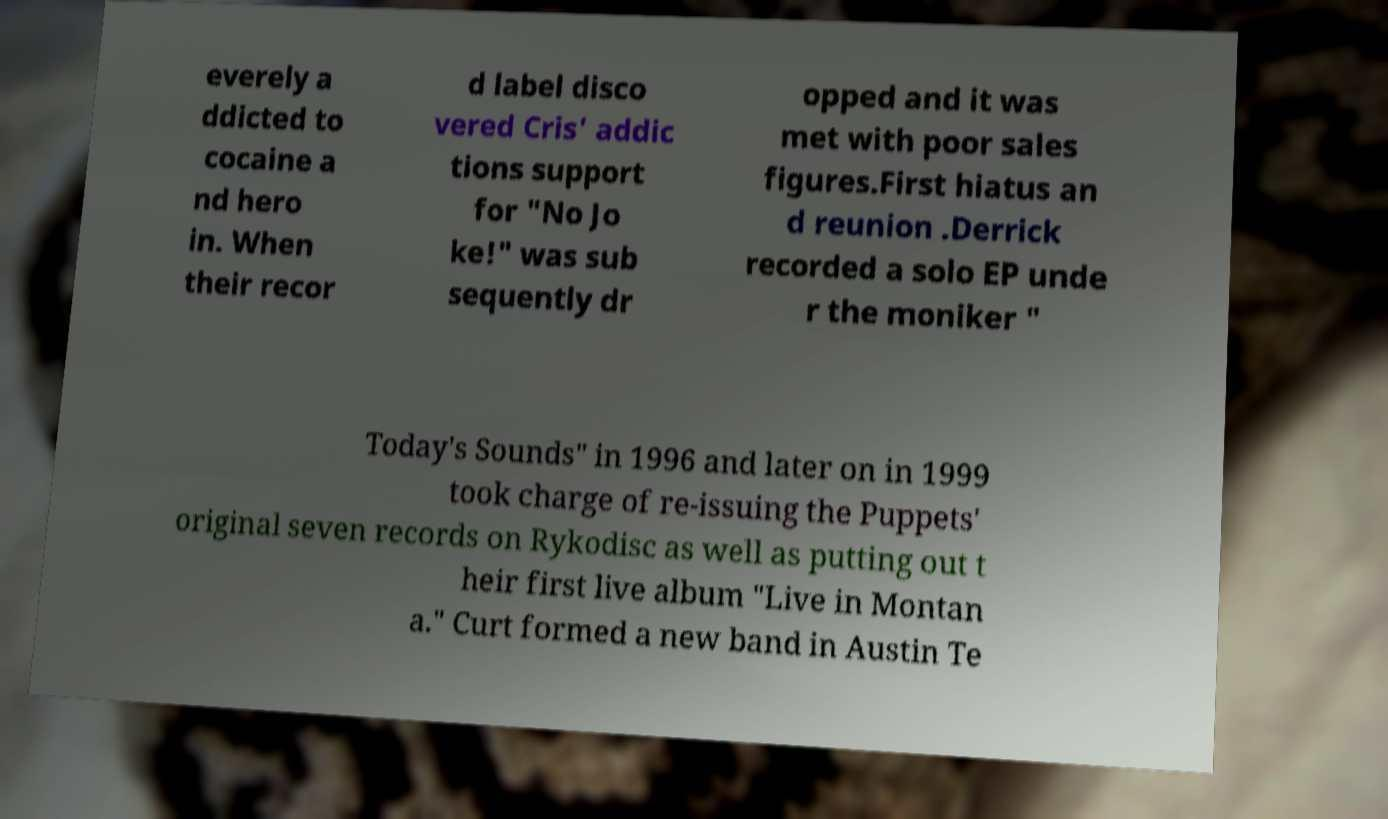Could you extract and type out the text from this image? everely a ddicted to cocaine a nd hero in. When their recor d label disco vered Cris' addic tions support for "No Jo ke!" was sub sequently dr opped and it was met with poor sales figures.First hiatus an d reunion .Derrick recorded a solo EP unde r the moniker " Today's Sounds" in 1996 and later on in 1999 took charge of re-issuing the Puppets' original seven records on Rykodisc as well as putting out t heir first live album "Live in Montan a." Curt formed a new band in Austin Te 